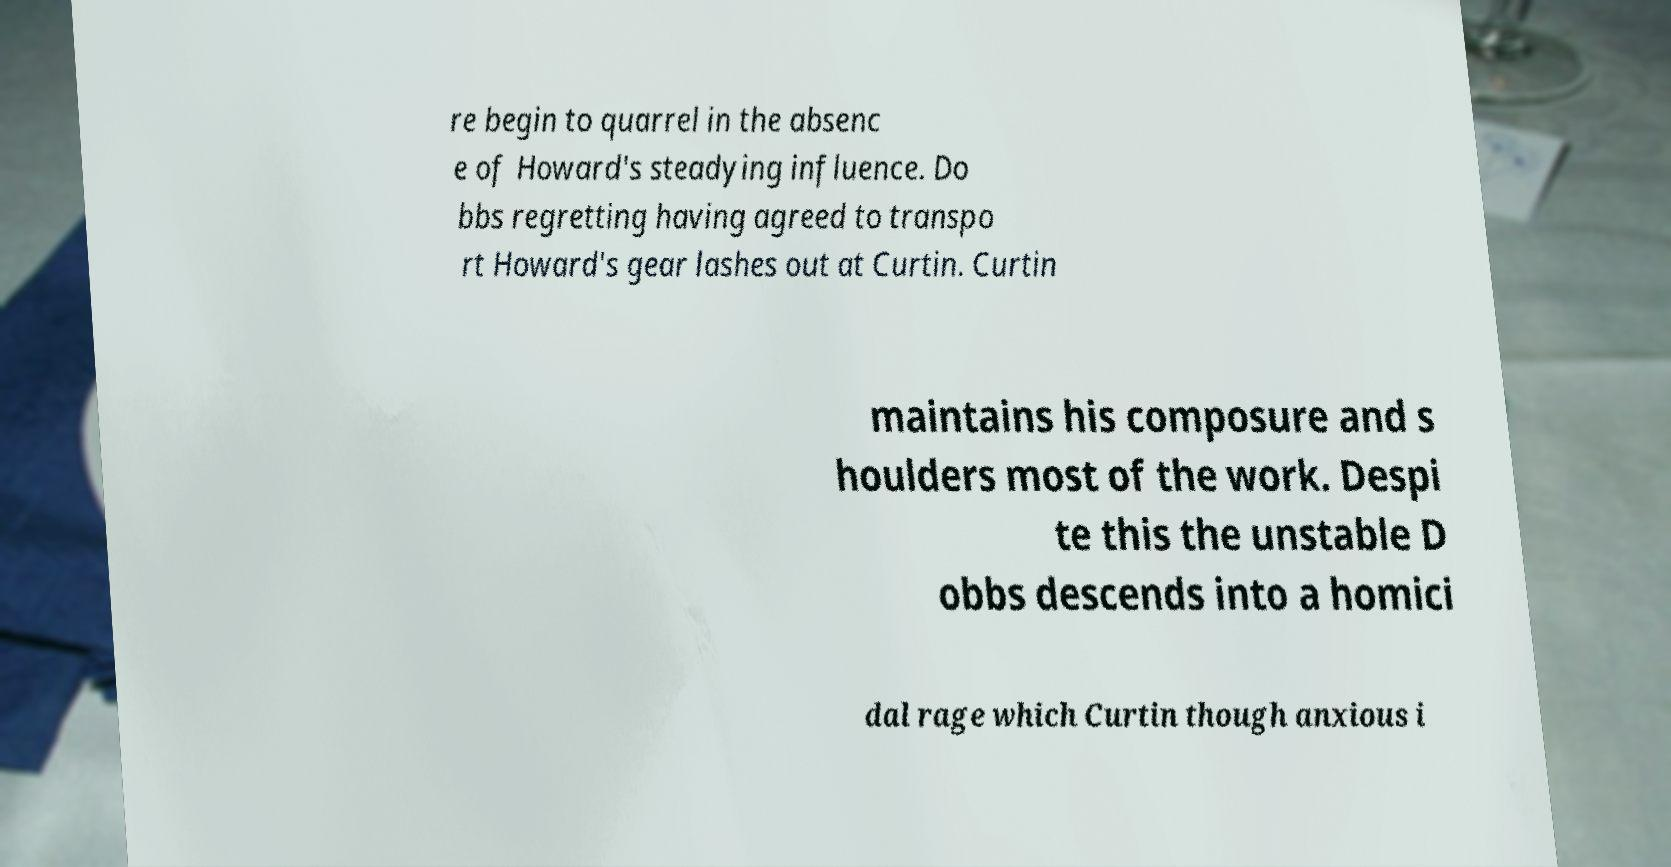Can you accurately transcribe the text from the provided image for me? re begin to quarrel in the absenc e of Howard's steadying influence. Do bbs regretting having agreed to transpo rt Howard's gear lashes out at Curtin. Curtin maintains his composure and s houlders most of the work. Despi te this the unstable D obbs descends into a homici dal rage which Curtin though anxious i 